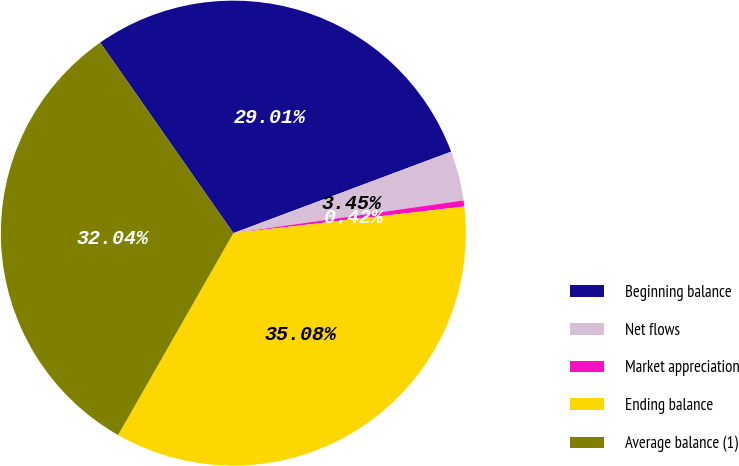Convert chart. <chart><loc_0><loc_0><loc_500><loc_500><pie_chart><fcel>Beginning balance<fcel>Net flows<fcel>Market appreciation<fcel>Ending balance<fcel>Average balance (1)<nl><fcel>29.01%<fcel>3.45%<fcel>0.42%<fcel>35.08%<fcel>32.04%<nl></chart> 